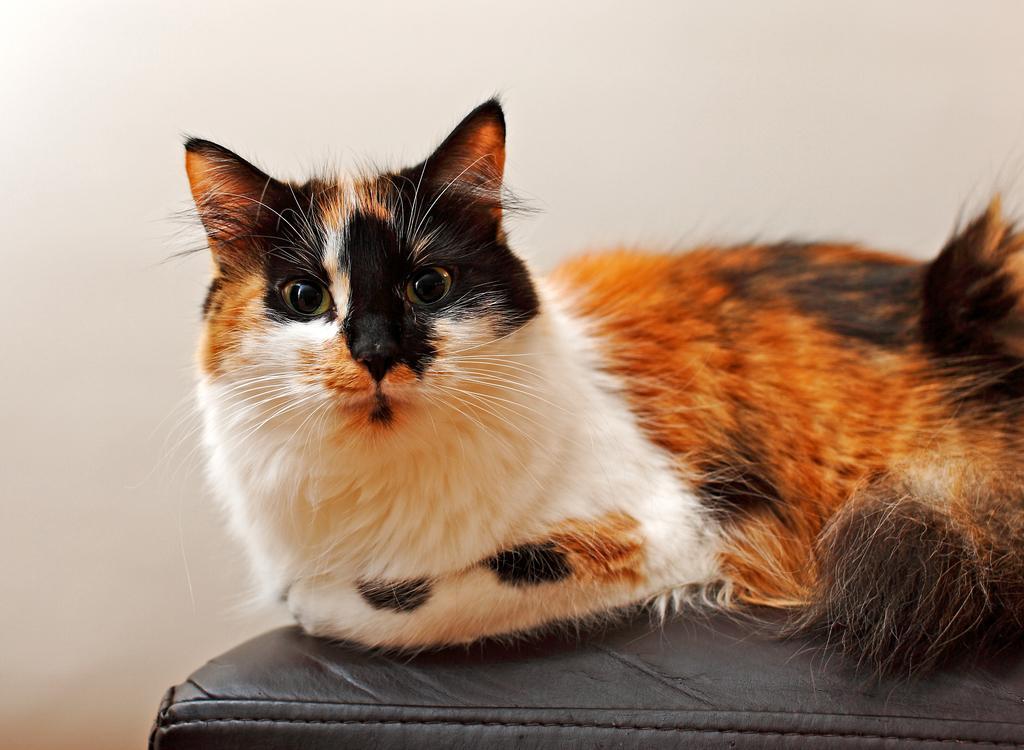Could you give a brief overview of what you see in this image? A cat is sitting on a black surface. At the back there is a white wall. 